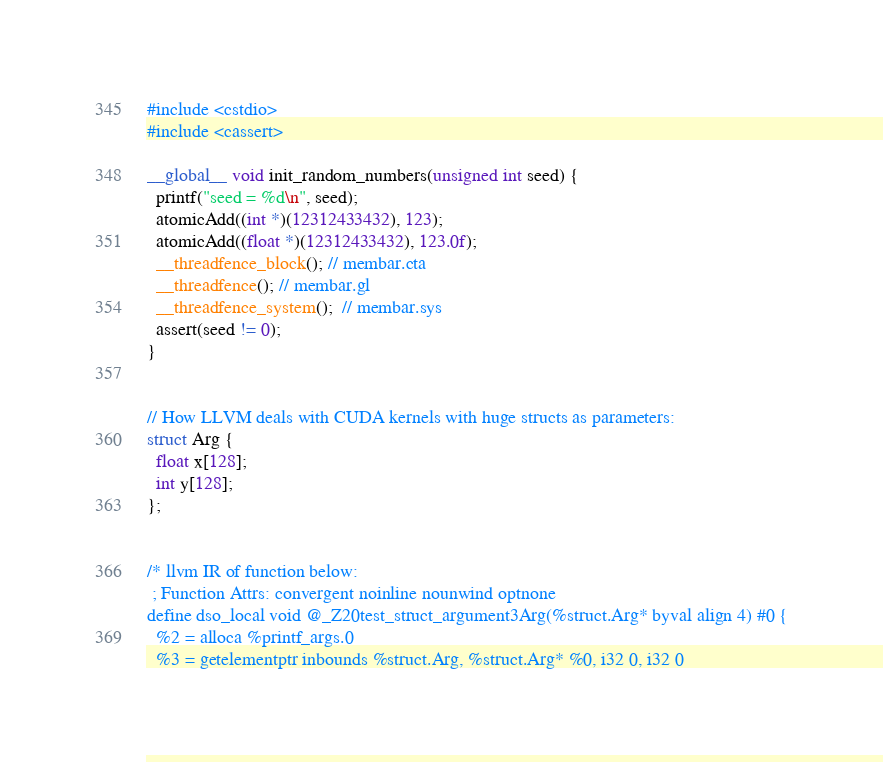<code> <loc_0><loc_0><loc_500><loc_500><_Cuda_>#include <cstdio>
#include <cassert>

__global__ void init_random_numbers(unsigned int seed) {
  printf("seed = %d\n", seed);
  atomicAdd((int *)(12312433432), 123);
  atomicAdd((float *)(12312433432), 123.0f);
  __threadfence_block(); // membar.cta
  __threadfence(); // membar.gl
  __threadfence_system();  // membar.sys
  assert(seed != 0);
}


// How LLVM deals with CUDA kernels with huge structs as parameters:
struct Arg {
  float x[128];
  int y[128];
};


/* llvm IR of function below:
 ; Function Attrs: convergent noinline nounwind optnone
define dso_local void @_Z20test_struct_argument3Arg(%struct.Arg* byval align 4) #0 {
  %2 = alloca %printf_args.0
  %3 = getelementptr inbounds %struct.Arg, %struct.Arg* %0, i32 0, i32 0</code> 